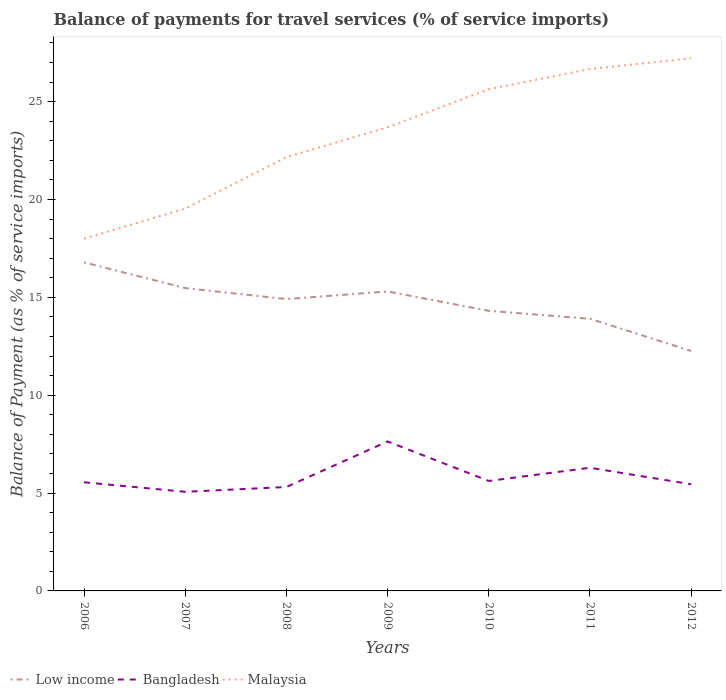How many different coloured lines are there?
Your answer should be compact. 3. Is the number of lines equal to the number of legend labels?
Your answer should be very brief. Yes. Across all years, what is the maximum balance of payments for travel services in Malaysia?
Your answer should be very brief. 18. What is the total balance of payments for travel services in Bangladesh in the graph?
Keep it short and to the point. 2.19. What is the difference between the highest and the second highest balance of payments for travel services in Malaysia?
Your answer should be very brief. 9.22. What is the difference between the highest and the lowest balance of payments for travel services in Malaysia?
Your response must be concise. 4. Is the balance of payments for travel services in Low income strictly greater than the balance of payments for travel services in Malaysia over the years?
Give a very brief answer. Yes. How many lines are there?
Your response must be concise. 3. Are the values on the major ticks of Y-axis written in scientific E-notation?
Ensure brevity in your answer.  No. Where does the legend appear in the graph?
Make the answer very short. Bottom left. What is the title of the graph?
Ensure brevity in your answer.  Balance of payments for travel services (% of service imports). What is the label or title of the X-axis?
Your answer should be compact. Years. What is the label or title of the Y-axis?
Provide a succinct answer. Balance of Payment (as % of service imports). What is the Balance of Payment (as % of service imports) in Low income in 2006?
Your answer should be compact. 16.79. What is the Balance of Payment (as % of service imports) in Bangladesh in 2006?
Provide a short and direct response. 5.55. What is the Balance of Payment (as % of service imports) in Malaysia in 2006?
Ensure brevity in your answer.  18. What is the Balance of Payment (as % of service imports) in Low income in 2007?
Provide a short and direct response. 15.47. What is the Balance of Payment (as % of service imports) of Bangladesh in 2007?
Make the answer very short. 5.06. What is the Balance of Payment (as % of service imports) of Malaysia in 2007?
Your answer should be very brief. 19.54. What is the Balance of Payment (as % of service imports) of Low income in 2008?
Your answer should be compact. 14.91. What is the Balance of Payment (as % of service imports) in Bangladesh in 2008?
Provide a succinct answer. 5.31. What is the Balance of Payment (as % of service imports) of Malaysia in 2008?
Make the answer very short. 22.16. What is the Balance of Payment (as % of service imports) of Low income in 2009?
Give a very brief answer. 15.3. What is the Balance of Payment (as % of service imports) of Bangladesh in 2009?
Your answer should be compact. 7.64. What is the Balance of Payment (as % of service imports) of Malaysia in 2009?
Your answer should be compact. 23.69. What is the Balance of Payment (as % of service imports) of Low income in 2010?
Provide a succinct answer. 14.31. What is the Balance of Payment (as % of service imports) in Bangladesh in 2010?
Ensure brevity in your answer.  5.62. What is the Balance of Payment (as % of service imports) of Malaysia in 2010?
Offer a terse response. 25.64. What is the Balance of Payment (as % of service imports) in Low income in 2011?
Offer a very short reply. 13.9. What is the Balance of Payment (as % of service imports) in Bangladesh in 2011?
Your answer should be very brief. 6.29. What is the Balance of Payment (as % of service imports) in Malaysia in 2011?
Offer a very short reply. 26.67. What is the Balance of Payment (as % of service imports) in Low income in 2012?
Your answer should be very brief. 12.26. What is the Balance of Payment (as % of service imports) of Bangladesh in 2012?
Your answer should be compact. 5.45. What is the Balance of Payment (as % of service imports) of Malaysia in 2012?
Your answer should be very brief. 27.22. Across all years, what is the maximum Balance of Payment (as % of service imports) of Low income?
Keep it short and to the point. 16.79. Across all years, what is the maximum Balance of Payment (as % of service imports) of Bangladesh?
Provide a succinct answer. 7.64. Across all years, what is the maximum Balance of Payment (as % of service imports) of Malaysia?
Offer a terse response. 27.22. Across all years, what is the minimum Balance of Payment (as % of service imports) in Low income?
Your response must be concise. 12.26. Across all years, what is the minimum Balance of Payment (as % of service imports) in Bangladesh?
Give a very brief answer. 5.06. Across all years, what is the minimum Balance of Payment (as % of service imports) in Malaysia?
Your answer should be compact. 18. What is the total Balance of Payment (as % of service imports) of Low income in the graph?
Provide a short and direct response. 102.95. What is the total Balance of Payment (as % of service imports) of Bangladesh in the graph?
Ensure brevity in your answer.  40.93. What is the total Balance of Payment (as % of service imports) in Malaysia in the graph?
Make the answer very short. 162.91. What is the difference between the Balance of Payment (as % of service imports) of Low income in 2006 and that in 2007?
Give a very brief answer. 1.32. What is the difference between the Balance of Payment (as % of service imports) of Bangladesh in 2006 and that in 2007?
Make the answer very short. 0.49. What is the difference between the Balance of Payment (as % of service imports) in Malaysia in 2006 and that in 2007?
Keep it short and to the point. -1.54. What is the difference between the Balance of Payment (as % of service imports) of Low income in 2006 and that in 2008?
Offer a very short reply. 1.88. What is the difference between the Balance of Payment (as % of service imports) in Bangladesh in 2006 and that in 2008?
Provide a succinct answer. 0.24. What is the difference between the Balance of Payment (as % of service imports) in Malaysia in 2006 and that in 2008?
Give a very brief answer. -4.16. What is the difference between the Balance of Payment (as % of service imports) of Low income in 2006 and that in 2009?
Your answer should be very brief. 1.49. What is the difference between the Balance of Payment (as % of service imports) of Bangladesh in 2006 and that in 2009?
Provide a short and direct response. -2.09. What is the difference between the Balance of Payment (as % of service imports) in Malaysia in 2006 and that in 2009?
Offer a very short reply. -5.69. What is the difference between the Balance of Payment (as % of service imports) of Low income in 2006 and that in 2010?
Make the answer very short. 2.48. What is the difference between the Balance of Payment (as % of service imports) in Bangladesh in 2006 and that in 2010?
Give a very brief answer. -0.07. What is the difference between the Balance of Payment (as % of service imports) in Malaysia in 2006 and that in 2010?
Offer a terse response. -7.64. What is the difference between the Balance of Payment (as % of service imports) of Low income in 2006 and that in 2011?
Keep it short and to the point. 2.88. What is the difference between the Balance of Payment (as % of service imports) of Bangladesh in 2006 and that in 2011?
Offer a very short reply. -0.74. What is the difference between the Balance of Payment (as % of service imports) of Malaysia in 2006 and that in 2011?
Give a very brief answer. -8.67. What is the difference between the Balance of Payment (as % of service imports) of Low income in 2006 and that in 2012?
Keep it short and to the point. 4.53. What is the difference between the Balance of Payment (as % of service imports) in Bangladesh in 2006 and that in 2012?
Keep it short and to the point. 0.1. What is the difference between the Balance of Payment (as % of service imports) of Malaysia in 2006 and that in 2012?
Your answer should be compact. -9.22. What is the difference between the Balance of Payment (as % of service imports) in Low income in 2007 and that in 2008?
Provide a short and direct response. 0.56. What is the difference between the Balance of Payment (as % of service imports) in Bangladesh in 2007 and that in 2008?
Your answer should be compact. -0.25. What is the difference between the Balance of Payment (as % of service imports) of Malaysia in 2007 and that in 2008?
Ensure brevity in your answer.  -2.63. What is the difference between the Balance of Payment (as % of service imports) of Low income in 2007 and that in 2009?
Offer a very short reply. 0.17. What is the difference between the Balance of Payment (as % of service imports) in Bangladesh in 2007 and that in 2009?
Your response must be concise. -2.57. What is the difference between the Balance of Payment (as % of service imports) in Malaysia in 2007 and that in 2009?
Offer a terse response. -4.15. What is the difference between the Balance of Payment (as % of service imports) of Low income in 2007 and that in 2010?
Give a very brief answer. 1.16. What is the difference between the Balance of Payment (as % of service imports) in Bangladesh in 2007 and that in 2010?
Make the answer very short. -0.55. What is the difference between the Balance of Payment (as % of service imports) in Malaysia in 2007 and that in 2010?
Your answer should be very brief. -6.1. What is the difference between the Balance of Payment (as % of service imports) in Low income in 2007 and that in 2011?
Your response must be concise. 1.57. What is the difference between the Balance of Payment (as % of service imports) of Bangladesh in 2007 and that in 2011?
Your answer should be very brief. -1.23. What is the difference between the Balance of Payment (as % of service imports) in Malaysia in 2007 and that in 2011?
Ensure brevity in your answer.  -7.13. What is the difference between the Balance of Payment (as % of service imports) of Low income in 2007 and that in 2012?
Ensure brevity in your answer.  3.21. What is the difference between the Balance of Payment (as % of service imports) in Bangladesh in 2007 and that in 2012?
Provide a succinct answer. -0.38. What is the difference between the Balance of Payment (as % of service imports) in Malaysia in 2007 and that in 2012?
Give a very brief answer. -7.68. What is the difference between the Balance of Payment (as % of service imports) in Low income in 2008 and that in 2009?
Your answer should be compact. -0.39. What is the difference between the Balance of Payment (as % of service imports) of Bangladesh in 2008 and that in 2009?
Provide a succinct answer. -2.33. What is the difference between the Balance of Payment (as % of service imports) in Malaysia in 2008 and that in 2009?
Ensure brevity in your answer.  -1.53. What is the difference between the Balance of Payment (as % of service imports) in Low income in 2008 and that in 2010?
Keep it short and to the point. 0.6. What is the difference between the Balance of Payment (as % of service imports) of Bangladesh in 2008 and that in 2010?
Ensure brevity in your answer.  -0.31. What is the difference between the Balance of Payment (as % of service imports) of Malaysia in 2008 and that in 2010?
Your answer should be compact. -3.47. What is the difference between the Balance of Payment (as % of service imports) of Low income in 2008 and that in 2011?
Give a very brief answer. 1.01. What is the difference between the Balance of Payment (as % of service imports) in Bangladesh in 2008 and that in 2011?
Make the answer very short. -0.98. What is the difference between the Balance of Payment (as % of service imports) in Malaysia in 2008 and that in 2011?
Give a very brief answer. -4.5. What is the difference between the Balance of Payment (as % of service imports) in Low income in 2008 and that in 2012?
Give a very brief answer. 2.65. What is the difference between the Balance of Payment (as % of service imports) of Bangladesh in 2008 and that in 2012?
Offer a very short reply. -0.14. What is the difference between the Balance of Payment (as % of service imports) of Malaysia in 2008 and that in 2012?
Provide a short and direct response. -5.05. What is the difference between the Balance of Payment (as % of service imports) of Low income in 2009 and that in 2010?
Make the answer very short. 0.99. What is the difference between the Balance of Payment (as % of service imports) of Bangladesh in 2009 and that in 2010?
Offer a very short reply. 2.02. What is the difference between the Balance of Payment (as % of service imports) in Malaysia in 2009 and that in 2010?
Your answer should be very brief. -1.95. What is the difference between the Balance of Payment (as % of service imports) in Low income in 2009 and that in 2011?
Make the answer very short. 1.4. What is the difference between the Balance of Payment (as % of service imports) of Bangladesh in 2009 and that in 2011?
Ensure brevity in your answer.  1.34. What is the difference between the Balance of Payment (as % of service imports) in Malaysia in 2009 and that in 2011?
Provide a short and direct response. -2.98. What is the difference between the Balance of Payment (as % of service imports) in Low income in 2009 and that in 2012?
Offer a very short reply. 3.04. What is the difference between the Balance of Payment (as % of service imports) in Bangladesh in 2009 and that in 2012?
Provide a succinct answer. 2.19. What is the difference between the Balance of Payment (as % of service imports) in Malaysia in 2009 and that in 2012?
Keep it short and to the point. -3.53. What is the difference between the Balance of Payment (as % of service imports) of Low income in 2010 and that in 2011?
Make the answer very short. 0.41. What is the difference between the Balance of Payment (as % of service imports) in Bangladesh in 2010 and that in 2011?
Keep it short and to the point. -0.67. What is the difference between the Balance of Payment (as % of service imports) in Malaysia in 2010 and that in 2011?
Provide a succinct answer. -1.03. What is the difference between the Balance of Payment (as % of service imports) in Low income in 2010 and that in 2012?
Your answer should be compact. 2.05. What is the difference between the Balance of Payment (as % of service imports) in Bangladesh in 2010 and that in 2012?
Make the answer very short. 0.17. What is the difference between the Balance of Payment (as % of service imports) in Malaysia in 2010 and that in 2012?
Ensure brevity in your answer.  -1.58. What is the difference between the Balance of Payment (as % of service imports) in Low income in 2011 and that in 2012?
Your response must be concise. 1.64. What is the difference between the Balance of Payment (as % of service imports) of Bangladesh in 2011 and that in 2012?
Provide a succinct answer. 0.84. What is the difference between the Balance of Payment (as % of service imports) of Malaysia in 2011 and that in 2012?
Make the answer very short. -0.55. What is the difference between the Balance of Payment (as % of service imports) of Low income in 2006 and the Balance of Payment (as % of service imports) of Bangladesh in 2007?
Keep it short and to the point. 11.72. What is the difference between the Balance of Payment (as % of service imports) in Low income in 2006 and the Balance of Payment (as % of service imports) in Malaysia in 2007?
Your answer should be compact. -2.75. What is the difference between the Balance of Payment (as % of service imports) in Bangladesh in 2006 and the Balance of Payment (as % of service imports) in Malaysia in 2007?
Ensure brevity in your answer.  -13.99. What is the difference between the Balance of Payment (as % of service imports) in Low income in 2006 and the Balance of Payment (as % of service imports) in Bangladesh in 2008?
Ensure brevity in your answer.  11.48. What is the difference between the Balance of Payment (as % of service imports) in Low income in 2006 and the Balance of Payment (as % of service imports) in Malaysia in 2008?
Give a very brief answer. -5.37. What is the difference between the Balance of Payment (as % of service imports) of Bangladesh in 2006 and the Balance of Payment (as % of service imports) of Malaysia in 2008?
Ensure brevity in your answer.  -16.61. What is the difference between the Balance of Payment (as % of service imports) in Low income in 2006 and the Balance of Payment (as % of service imports) in Bangladesh in 2009?
Make the answer very short. 9.15. What is the difference between the Balance of Payment (as % of service imports) in Low income in 2006 and the Balance of Payment (as % of service imports) in Malaysia in 2009?
Ensure brevity in your answer.  -6.9. What is the difference between the Balance of Payment (as % of service imports) of Bangladesh in 2006 and the Balance of Payment (as % of service imports) of Malaysia in 2009?
Keep it short and to the point. -18.14. What is the difference between the Balance of Payment (as % of service imports) of Low income in 2006 and the Balance of Payment (as % of service imports) of Bangladesh in 2010?
Provide a short and direct response. 11.17. What is the difference between the Balance of Payment (as % of service imports) in Low income in 2006 and the Balance of Payment (as % of service imports) in Malaysia in 2010?
Your response must be concise. -8.85. What is the difference between the Balance of Payment (as % of service imports) of Bangladesh in 2006 and the Balance of Payment (as % of service imports) of Malaysia in 2010?
Make the answer very short. -20.08. What is the difference between the Balance of Payment (as % of service imports) of Low income in 2006 and the Balance of Payment (as % of service imports) of Bangladesh in 2011?
Keep it short and to the point. 10.5. What is the difference between the Balance of Payment (as % of service imports) of Low income in 2006 and the Balance of Payment (as % of service imports) of Malaysia in 2011?
Ensure brevity in your answer.  -9.88. What is the difference between the Balance of Payment (as % of service imports) of Bangladesh in 2006 and the Balance of Payment (as % of service imports) of Malaysia in 2011?
Ensure brevity in your answer.  -21.12. What is the difference between the Balance of Payment (as % of service imports) in Low income in 2006 and the Balance of Payment (as % of service imports) in Bangladesh in 2012?
Provide a short and direct response. 11.34. What is the difference between the Balance of Payment (as % of service imports) of Low income in 2006 and the Balance of Payment (as % of service imports) of Malaysia in 2012?
Offer a very short reply. -10.43. What is the difference between the Balance of Payment (as % of service imports) of Bangladesh in 2006 and the Balance of Payment (as % of service imports) of Malaysia in 2012?
Provide a succinct answer. -21.67. What is the difference between the Balance of Payment (as % of service imports) of Low income in 2007 and the Balance of Payment (as % of service imports) of Bangladesh in 2008?
Offer a terse response. 10.16. What is the difference between the Balance of Payment (as % of service imports) of Low income in 2007 and the Balance of Payment (as % of service imports) of Malaysia in 2008?
Your answer should be very brief. -6.69. What is the difference between the Balance of Payment (as % of service imports) of Bangladesh in 2007 and the Balance of Payment (as % of service imports) of Malaysia in 2008?
Your answer should be compact. -17.1. What is the difference between the Balance of Payment (as % of service imports) of Low income in 2007 and the Balance of Payment (as % of service imports) of Bangladesh in 2009?
Your response must be concise. 7.83. What is the difference between the Balance of Payment (as % of service imports) in Low income in 2007 and the Balance of Payment (as % of service imports) in Malaysia in 2009?
Keep it short and to the point. -8.22. What is the difference between the Balance of Payment (as % of service imports) in Bangladesh in 2007 and the Balance of Payment (as % of service imports) in Malaysia in 2009?
Make the answer very short. -18.63. What is the difference between the Balance of Payment (as % of service imports) in Low income in 2007 and the Balance of Payment (as % of service imports) in Bangladesh in 2010?
Ensure brevity in your answer.  9.85. What is the difference between the Balance of Payment (as % of service imports) of Low income in 2007 and the Balance of Payment (as % of service imports) of Malaysia in 2010?
Provide a short and direct response. -10.16. What is the difference between the Balance of Payment (as % of service imports) of Bangladesh in 2007 and the Balance of Payment (as % of service imports) of Malaysia in 2010?
Provide a short and direct response. -20.57. What is the difference between the Balance of Payment (as % of service imports) of Low income in 2007 and the Balance of Payment (as % of service imports) of Bangladesh in 2011?
Your answer should be very brief. 9.18. What is the difference between the Balance of Payment (as % of service imports) of Low income in 2007 and the Balance of Payment (as % of service imports) of Malaysia in 2011?
Ensure brevity in your answer.  -11.19. What is the difference between the Balance of Payment (as % of service imports) in Bangladesh in 2007 and the Balance of Payment (as % of service imports) in Malaysia in 2011?
Keep it short and to the point. -21.6. What is the difference between the Balance of Payment (as % of service imports) in Low income in 2007 and the Balance of Payment (as % of service imports) in Bangladesh in 2012?
Offer a terse response. 10.02. What is the difference between the Balance of Payment (as % of service imports) of Low income in 2007 and the Balance of Payment (as % of service imports) of Malaysia in 2012?
Your answer should be very brief. -11.74. What is the difference between the Balance of Payment (as % of service imports) of Bangladesh in 2007 and the Balance of Payment (as % of service imports) of Malaysia in 2012?
Provide a short and direct response. -22.15. What is the difference between the Balance of Payment (as % of service imports) of Low income in 2008 and the Balance of Payment (as % of service imports) of Bangladesh in 2009?
Offer a terse response. 7.27. What is the difference between the Balance of Payment (as % of service imports) of Low income in 2008 and the Balance of Payment (as % of service imports) of Malaysia in 2009?
Keep it short and to the point. -8.78. What is the difference between the Balance of Payment (as % of service imports) of Bangladesh in 2008 and the Balance of Payment (as % of service imports) of Malaysia in 2009?
Make the answer very short. -18.38. What is the difference between the Balance of Payment (as % of service imports) of Low income in 2008 and the Balance of Payment (as % of service imports) of Bangladesh in 2010?
Your answer should be very brief. 9.29. What is the difference between the Balance of Payment (as % of service imports) of Low income in 2008 and the Balance of Payment (as % of service imports) of Malaysia in 2010?
Give a very brief answer. -10.72. What is the difference between the Balance of Payment (as % of service imports) of Bangladesh in 2008 and the Balance of Payment (as % of service imports) of Malaysia in 2010?
Ensure brevity in your answer.  -20.33. What is the difference between the Balance of Payment (as % of service imports) of Low income in 2008 and the Balance of Payment (as % of service imports) of Bangladesh in 2011?
Provide a succinct answer. 8.62. What is the difference between the Balance of Payment (as % of service imports) of Low income in 2008 and the Balance of Payment (as % of service imports) of Malaysia in 2011?
Offer a terse response. -11.75. What is the difference between the Balance of Payment (as % of service imports) of Bangladesh in 2008 and the Balance of Payment (as % of service imports) of Malaysia in 2011?
Your answer should be very brief. -21.36. What is the difference between the Balance of Payment (as % of service imports) in Low income in 2008 and the Balance of Payment (as % of service imports) in Bangladesh in 2012?
Your answer should be compact. 9.46. What is the difference between the Balance of Payment (as % of service imports) in Low income in 2008 and the Balance of Payment (as % of service imports) in Malaysia in 2012?
Keep it short and to the point. -12.31. What is the difference between the Balance of Payment (as % of service imports) in Bangladesh in 2008 and the Balance of Payment (as % of service imports) in Malaysia in 2012?
Keep it short and to the point. -21.91. What is the difference between the Balance of Payment (as % of service imports) of Low income in 2009 and the Balance of Payment (as % of service imports) of Bangladesh in 2010?
Your answer should be compact. 9.68. What is the difference between the Balance of Payment (as % of service imports) in Low income in 2009 and the Balance of Payment (as % of service imports) in Malaysia in 2010?
Provide a succinct answer. -10.34. What is the difference between the Balance of Payment (as % of service imports) of Bangladesh in 2009 and the Balance of Payment (as % of service imports) of Malaysia in 2010?
Your answer should be compact. -18. What is the difference between the Balance of Payment (as % of service imports) of Low income in 2009 and the Balance of Payment (as % of service imports) of Bangladesh in 2011?
Your response must be concise. 9.01. What is the difference between the Balance of Payment (as % of service imports) of Low income in 2009 and the Balance of Payment (as % of service imports) of Malaysia in 2011?
Provide a succinct answer. -11.37. What is the difference between the Balance of Payment (as % of service imports) in Bangladesh in 2009 and the Balance of Payment (as % of service imports) in Malaysia in 2011?
Offer a terse response. -19.03. What is the difference between the Balance of Payment (as % of service imports) in Low income in 2009 and the Balance of Payment (as % of service imports) in Bangladesh in 2012?
Make the answer very short. 9.85. What is the difference between the Balance of Payment (as % of service imports) in Low income in 2009 and the Balance of Payment (as % of service imports) in Malaysia in 2012?
Your answer should be compact. -11.92. What is the difference between the Balance of Payment (as % of service imports) in Bangladesh in 2009 and the Balance of Payment (as % of service imports) in Malaysia in 2012?
Ensure brevity in your answer.  -19.58. What is the difference between the Balance of Payment (as % of service imports) in Low income in 2010 and the Balance of Payment (as % of service imports) in Bangladesh in 2011?
Provide a succinct answer. 8.02. What is the difference between the Balance of Payment (as % of service imports) of Low income in 2010 and the Balance of Payment (as % of service imports) of Malaysia in 2011?
Give a very brief answer. -12.35. What is the difference between the Balance of Payment (as % of service imports) in Bangladesh in 2010 and the Balance of Payment (as % of service imports) in Malaysia in 2011?
Provide a succinct answer. -21.05. What is the difference between the Balance of Payment (as % of service imports) of Low income in 2010 and the Balance of Payment (as % of service imports) of Bangladesh in 2012?
Make the answer very short. 8.86. What is the difference between the Balance of Payment (as % of service imports) in Low income in 2010 and the Balance of Payment (as % of service imports) in Malaysia in 2012?
Your answer should be compact. -12.91. What is the difference between the Balance of Payment (as % of service imports) in Bangladesh in 2010 and the Balance of Payment (as % of service imports) in Malaysia in 2012?
Make the answer very short. -21.6. What is the difference between the Balance of Payment (as % of service imports) of Low income in 2011 and the Balance of Payment (as % of service imports) of Bangladesh in 2012?
Make the answer very short. 8.46. What is the difference between the Balance of Payment (as % of service imports) of Low income in 2011 and the Balance of Payment (as % of service imports) of Malaysia in 2012?
Offer a terse response. -13.31. What is the difference between the Balance of Payment (as % of service imports) in Bangladesh in 2011 and the Balance of Payment (as % of service imports) in Malaysia in 2012?
Give a very brief answer. -20.92. What is the average Balance of Payment (as % of service imports) of Low income per year?
Your answer should be compact. 14.71. What is the average Balance of Payment (as % of service imports) of Bangladesh per year?
Give a very brief answer. 5.85. What is the average Balance of Payment (as % of service imports) in Malaysia per year?
Give a very brief answer. 23.27. In the year 2006, what is the difference between the Balance of Payment (as % of service imports) of Low income and Balance of Payment (as % of service imports) of Bangladesh?
Offer a terse response. 11.24. In the year 2006, what is the difference between the Balance of Payment (as % of service imports) of Low income and Balance of Payment (as % of service imports) of Malaysia?
Give a very brief answer. -1.21. In the year 2006, what is the difference between the Balance of Payment (as % of service imports) in Bangladesh and Balance of Payment (as % of service imports) in Malaysia?
Provide a short and direct response. -12.45. In the year 2007, what is the difference between the Balance of Payment (as % of service imports) in Low income and Balance of Payment (as % of service imports) in Bangladesh?
Offer a terse response. 10.41. In the year 2007, what is the difference between the Balance of Payment (as % of service imports) in Low income and Balance of Payment (as % of service imports) in Malaysia?
Give a very brief answer. -4.06. In the year 2007, what is the difference between the Balance of Payment (as % of service imports) in Bangladesh and Balance of Payment (as % of service imports) in Malaysia?
Your answer should be very brief. -14.47. In the year 2008, what is the difference between the Balance of Payment (as % of service imports) in Low income and Balance of Payment (as % of service imports) in Bangladesh?
Your response must be concise. 9.6. In the year 2008, what is the difference between the Balance of Payment (as % of service imports) in Low income and Balance of Payment (as % of service imports) in Malaysia?
Provide a short and direct response. -7.25. In the year 2008, what is the difference between the Balance of Payment (as % of service imports) in Bangladesh and Balance of Payment (as % of service imports) in Malaysia?
Your answer should be compact. -16.85. In the year 2009, what is the difference between the Balance of Payment (as % of service imports) of Low income and Balance of Payment (as % of service imports) of Bangladesh?
Provide a succinct answer. 7.66. In the year 2009, what is the difference between the Balance of Payment (as % of service imports) of Low income and Balance of Payment (as % of service imports) of Malaysia?
Your answer should be very brief. -8.39. In the year 2009, what is the difference between the Balance of Payment (as % of service imports) of Bangladesh and Balance of Payment (as % of service imports) of Malaysia?
Keep it short and to the point. -16.05. In the year 2010, what is the difference between the Balance of Payment (as % of service imports) of Low income and Balance of Payment (as % of service imports) of Bangladesh?
Give a very brief answer. 8.69. In the year 2010, what is the difference between the Balance of Payment (as % of service imports) of Low income and Balance of Payment (as % of service imports) of Malaysia?
Provide a short and direct response. -11.32. In the year 2010, what is the difference between the Balance of Payment (as % of service imports) in Bangladesh and Balance of Payment (as % of service imports) in Malaysia?
Your response must be concise. -20.02. In the year 2011, what is the difference between the Balance of Payment (as % of service imports) of Low income and Balance of Payment (as % of service imports) of Bangladesh?
Offer a very short reply. 7.61. In the year 2011, what is the difference between the Balance of Payment (as % of service imports) of Low income and Balance of Payment (as % of service imports) of Malaysia?
Provide a succinct answer. -12.76. In the year 2011, what is the difference between the Balance of Payment (as % of service imports) in Bangladesh and Balance of Payment (as % of service imports) in Malaysia?
Offer a terse response. -20.37. In the year 2012, what is the difference between the Balance of Payment (as % of service imports) in Low income and Balance of Payment (as % of service imports) in Bangladesh?
Provide a short and direct response. 6.81. In the year 2012, what is the difference between the Balance of Payment (as % of service imports) of Low income and Balance of Payment (as % of service imports) of Malaysia?
Make the answer very short. -14.96. In the year 2012, what is the difference between the Balance of Payment (as % of service imports) in Bangladesh and Balance of Payment (as % of service imports) in Malaysia?
Offer a terse response. -21.77. What is the ratio of the Balance of Payment (as % of service imports) of Low income in 2006 to that in 2007?
Offer a terse response. 1.09. What is the ratio of the Balance of Payment (as % of service imports) of Bangladesh in 2006 to that in 2007?
Provide a succinct answer. 1.1. What is the ratio of the Balance of Payment (as % of service imports) of Malaysia in 2006 to that in 2007?
Ensure brevity in your answer.  0.92. What is the ratio of the Balance of Payment (as % of service imports) of Low income in 2006 to that in 2008?
Give a very brief answer. 1.13. What is the ratio of the Balance of Payment (as % of service imports) of Bangladesh in 2006 to that in 2008?
Your answer should be compact. 1.05. What is the ratio of the Balance of Payment (as % of service imports) of Malaysia in 2006 to that in 2008?
Provide a succinct answer. 0.81. What is the ratio of the Balance of Payment (as % of service imports) in Low income in 2006 to that in 2009?
Ensure brevity in your answer.  1.1. What is the ratio of the Balance of Payment (as % of service imports) of Bangladesh in 2006 to that in 2009?
Your answer should be compact. 0.73. What is the ratio of the Balance of Payment (as % of service imports) of Malaysia in 2006 to that in 2009?
Make the answer very short. 0.76. What is the ratio of the Balance of Payment (as % of service imports) of Low income in 2006 to that in 2010?
Make the answer very short. 1.17. What is the ratio of the Balance of Payment (as % of service imports) in Malaysia in 2006 to that in 2010?
Provide a succinct answer. 0.7. What is the ratio of the Balance of Payment (as % of service imports) of Low income in 2006 to that in 2011?
Offer a terse response. 1.21. What is the ratio of the Balance of Payment (as % of service imports) in Bangladesh in 2006 to that in 2011?
Offer a very short reply. 0.88. What is the ratio of the Balance of Payment (as % of service imports) of Malaysia in 2006 to that in 2011?
Your answer should be compact. 0.68. What is the ratio of the Balance of Payment (as % of service imports) of Low income in 2006 to that in 2012?
Ensure brevity in your answer.  1.37. What is the ratio of the Balance of Payment (as % of service imports) in Bangladesh in 2006 to that in 2012?
Your answer should be compact. 1.02. What is the ratio of the Balance of Payment (as % of service imports) in Malaysia in 2006 to that in 2012?
Offer a terse response. 0.66. What is the ratio of the Balance of Payment (as % of service imports) in Low income in 2007 to that in 2008?
Your answer should be compact. 1.04. What is the ratio of the Balance of Payment (as % of service imports) of Bangladesh in 2007 to that in 2008?
Ensure brevity in your answer.  0.95. What is the ratio of the Balance of Payment (as % of service imports) of Malaysia in 2007 to that in 2008?
Provide a short and direct response. 0.88. What is the ratio of the Balance of Payment (as % of service imports) of Low income in 2007 to that in 2009?
Offer a terse response. 1.01. What is the ratio of the Balance of Payment (as % of service imports) of Bangladesh in 2007 to that in 2009?
Ensure brevity in your answer.  0.66. What is the ratio of the Balance of Payment (as % of service imports) in Malaysia in 2007 to that in 2009?
Provide a succinct answer. 0.82. What is the ratio of the Balance of Payment (as % of service imports) of Low income in 2007 to that in 2010?
Your answer should be compact. 1.08. What is the ratio of the Balance of Payment (as % of service imports) in Bangladesh in 2007 to that in 2010?
Keep it short and to the point. 0.9. What is the ratio of the Balance of Payment (as % of service imports) in Malaysia in 2007 to that in 2010?
Provide a succinct answer. 0.76. What is the ratio of the Balance of Payment (as % of service imports) in Low income in 2007 to that in 2011?
Make the answer very short. 1.11. What is the ratio of the Balance of Payment (as % of service imports) of Bangladesh in 2007 to that in 2011?
Offer a terse response. 0.8. What is the ratio of the Balance of Payment (as % of service imports) of Malaysia in 2007 to that in 2011?
Provide a short and direct response. 0.73. What is the ratio of the Balance of Payment (as % of service imports) of Low income in 2007 to that in 2012?
Your answer should be very brief. 1.26. What is the ratio of the Balance of Payment (as % of service imports) in Bangladesh in 2007 to that in 2012?
Provide a succinct answer. 0.93. What is the ratio of the Balance of Payment (as % of service imports) of Malaysia in 2007 to that in 2012?
Provide a short and direct response. 0.72. What is the ratio of the Balance of Payment (as % of service imports) of Low income in 2008 to that in 2009?
Provide a succinct answer. 0.97. What is the ratio of the Balance of Payment (as % of service imports) of Bangladesh in 2008 to that in 2009?
Your answer should be very brief. 0.7. What is the ratio of the Balance of Payment (as % of service imports) of Malaysia in 2008 to that in 2009?
Offer a very short reply. 0.94. What is the ratio of the Balance of Payment (as % of service imports) in Low income in 2008 to that in 2010?
Provide a succinct answer. 1.04. What is the ratio of the Balance of Payment (as % of service imports) in Bangladesh in 2008 to that in 2010?
Give a very brief answer. 0.95. What is the ratio of the Balance of Payment (as % of service imports) of Malaysia in 2008 to that in 2010?
Provide a succinct answer. 0.86. What is the ratio of the Balance of Payment (as % of service imports) in Low income in 2008 to that in 2011?
Offer a terse response. 1.07. What is the ratio of the Balance of Payment (as % of service imports) in Bangladesh in 2008 to that in 2011?
Provide a succinct answer. 0.84. What is the ratio of the Balance of Payment (as % of service imports) in Malaysia in 2008 to that in 2011?
Your answer should be very brief. 0.83. What is the ratio of the Balance of Payment (as % of service imports) of Low income in 2008 to that in 2012?
Ensure brevity in your answer.  1.22. What is the ratio of the Balance of Payment (as % of service imports) in Bangladesh in 2008 to that in 2012?
Ensure brevity in your answer.  0.97. What is the ratio of the Balance of Payment (as % of service imports) of Malaysia in 2008 to that in 2012?
Your response must be concise. 0.81. What is the ratio of the Balance of Payment (as % of service imports) of Low income in 2009 to that in 2010?
Give a very brief answer. 1.07. What is the ratio of the Balance of Payment (as % of service imports) in Bangladesh in 2009 to that in 2010?
Make the answer very short. 1.36. What is the ratio of the Balance of Payment (as % of service imports) in Malaysia in 2009 to that in 2010?
Your response must be concise. 0.92. What is the ratio of the Balance of Payment (as % of service imports) of Low income in 2009 to that in 2011?
Your response must be concise. 1.1. What is the ratio of the Balance of Payment (as % of service imports) of Bangladesh in 2009 to that in 2011?
Make the answer very short. 1.21. What is the ratio of the Balance of Payment (as % of service imports) in Malaysia in 2009 to that in 2011?
Offer a very short reply. 0.89. What is the ratio of the Balance of Payment (as % of service imports) in Low income in 2009 to that in 2012?
Provide a succinct answer. 1.25. What is the ratio of the Balance of Payment (as % of service imports) in Bangladesh in 2009 to that in 2012?
Your response must be concise. 1.4. What is the ratio of the Balance of Payment (as % of service imports) in Malaysia in 2009 to that in 2012?
Your response must be concise. 0.87. What is the ratio of the Balance of Payment (as % of service imports) of Low income in 2010 to that in 2011?
Your response must be concise. 1.03. What is the ratio of the Balance of Payment (as % of service imports) of Bangladesh in 2010 to that in 2011?
Provide a short and direct response. 0.89. What is the ratio of the Balance of Payment (as % of service imports) in Malaysia in 2010 to that in 2011?
Your response must be concise. 0.96. What is the ratio of the Balance of Payment (as % of service imports) in Low income in 2010 to that in 2012?
Your response must be concise. 1.17. What is the ratio of the Balance of Payment (as % of service imports) in Bangladesh in 2010 to that in 2012?
Offer a very short reply. 1.03. What is the ratio of the Balance of Payment (as % of service imports) in Malaysia in 2010 to that in 2012?
Provide a succinct answer. 0.94. What is the ratio of the Balance of Payment (as % of service imports) of Low income in 2011 to that in 2012?
Provide a short and direct response. 1.13. What is the ratio of the Balance of Payment (as % of service imports) of Bangladesh in 2011 to that in 2012?
Offer a terse response. 1.15. What is the ratio of the Balance of Payment (as % of service imports) of Malaysia in 2011 to that in 2012?
Ensure brevity in your answer.  0.98. What is the difference between the highest and the second highest Balance of Payment (as % of service imports) in Low income?
Offer a very short reply. 1.32. What is the difference between the highest and the second highest Balance of Payment (as % of service imports) of Bangladesh?
Give a very brief answer. 1.34. What is the difference between the highest and the second highest Balance of Payment (as % of service imports) of Malaysia?
Offer a very short reply. 0.55. What is the difference between the highest and the lowest Balance of Payment (as % of service imports) of Low income?
Keep it short and to the point. 4.53. What is the difference between the highest and the lowest Balance of Payment (as % of service imports) of Bangladesh?
Your answer should be compact. 2.57. What is the difference between the highest and the lowest Balance of Payment (as % of service imports) in Malaysia?
Offer a very short reply. 9.22. 